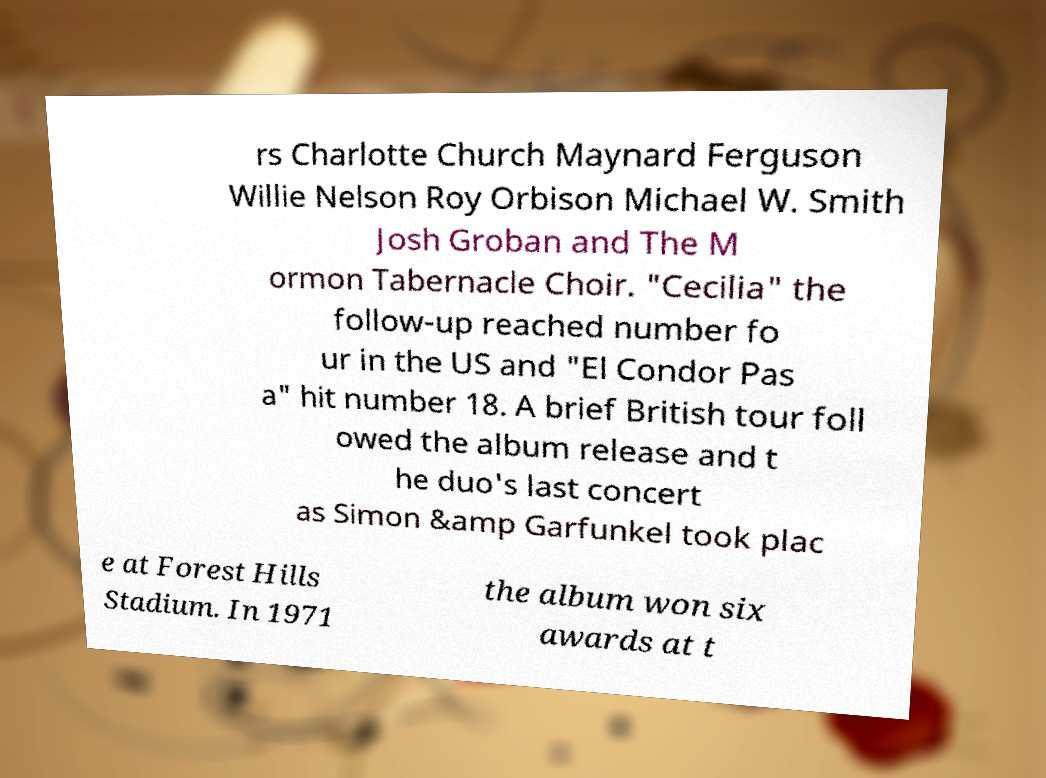Could you extract and type out the text from this image? rs Charlotte Church Maynard Ferguson Willie Nelson Roy Orbison Michael W. Smith Josh Groban and The M ormon Tabernacle Choir. "Cecilia" the follow-up reached number fo ur in the US and "El Condor Pas a" hit number 18. A brief British tour foll owed the album release and t he duo's last concert as Simon &amp Garfunkel took plac e at Forest Hills Stadium. In 1971 the album won six awards at t 